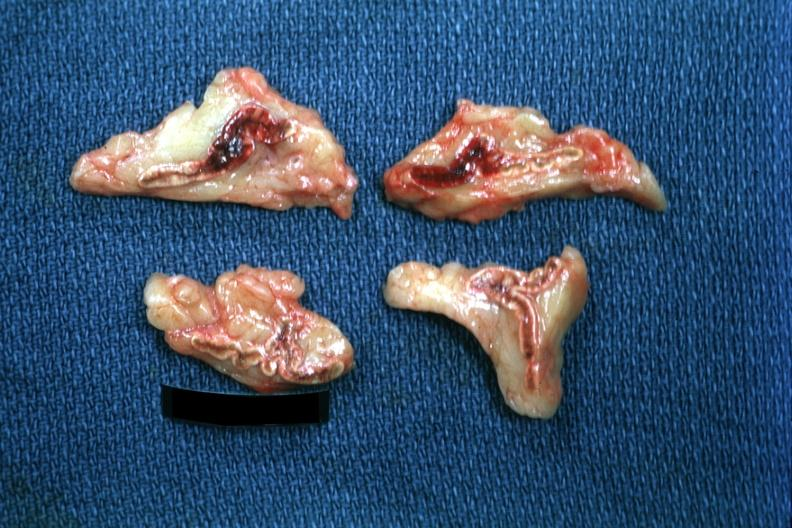s adrenal present?
Answer the question using a single word or phrase. Yes 